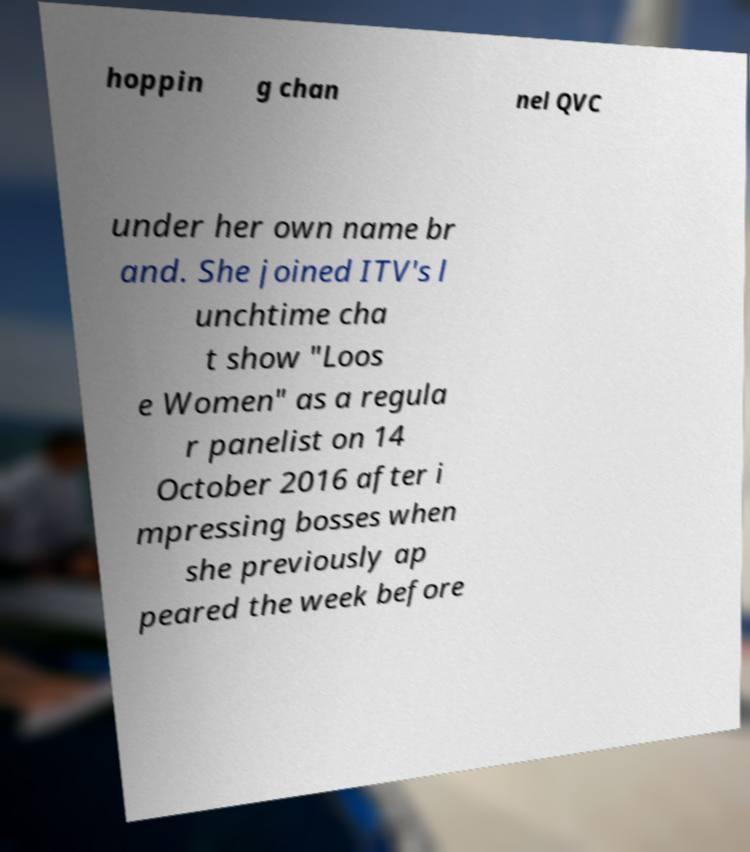I need the written content from this picture converted into text. Can you do that? hoppin g chan nel QVC under her own name br and. She joined ITV's l unchtime cha t show "Loos e Women" as a regula r panelist on 14 October 2016 after i mpressing bosses when she previously ap peared the week before 